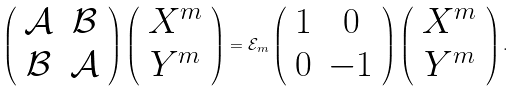Convert formula to latex. <formula><loc_0><loc_0><loc_500><loc_500>\left ( \begin{array} { c c } \mathcal { A } & \mathcal { B } \\ \mathcal { B } & \mathcal { A } \end{array} \right ) \left ( \begin{array} { c } X ^ { m } \\ Y ^ { m } \end{array} \right ) = \mathcal { E } _ { m } \left ( \begin{array} { c c } 1 & 0 \\ 0 & - 1 \end{array} \right ) \left ( \begin{array} { c } X ^ { m } \\ Y ^ { m } \end{array} \right ) .</formula> 